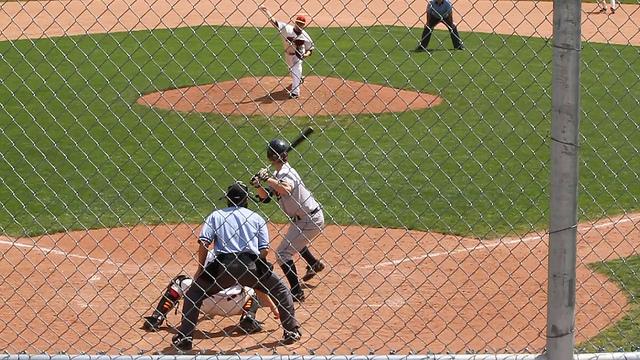Is this a pro game?
Short answer required. Yes. Is the ball being pitched?
Write a very short answer. Yes. What is this sport?
Concise answer only. Baseball. 